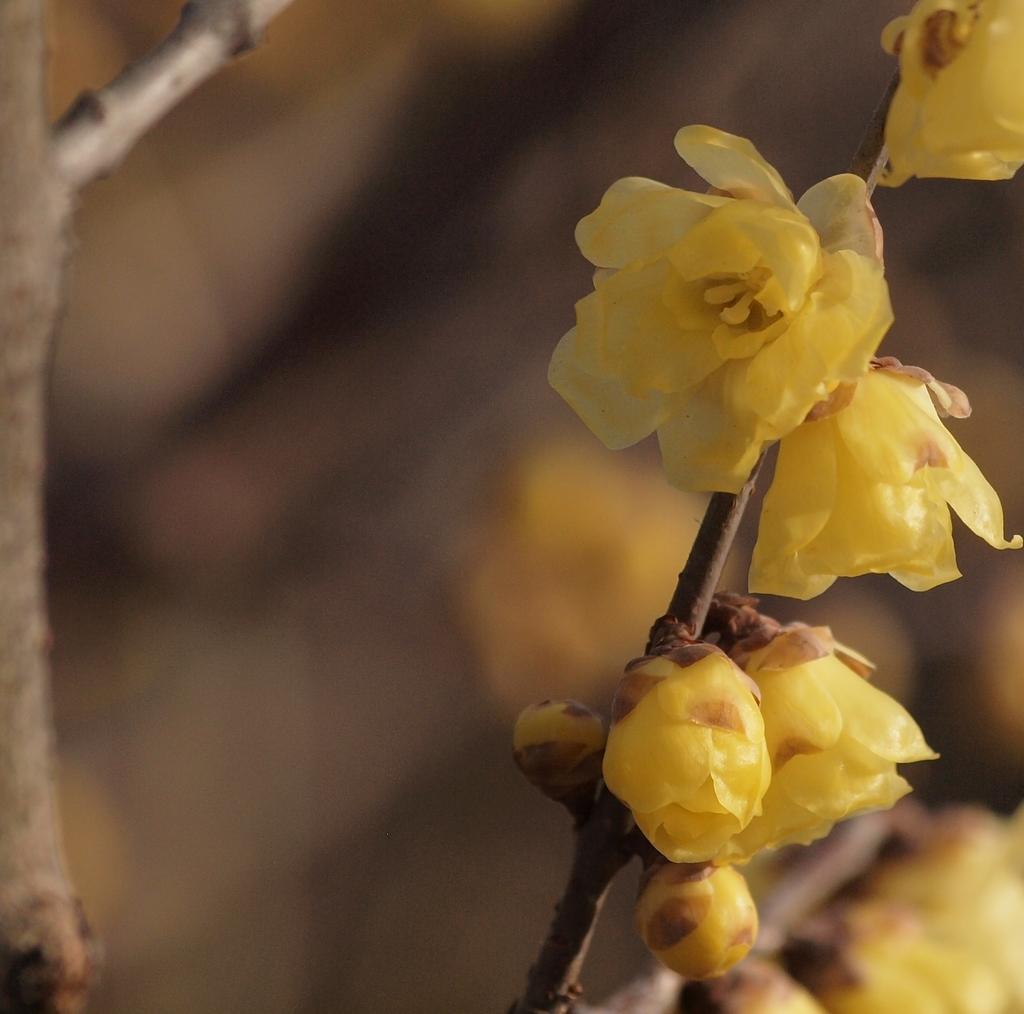Can you describe this image briefly? In this image I can see few yellow colour flowers in the front and in the background I can see a stick and I can see this image is blurry in the background. 